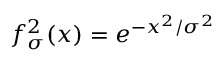Convert formula to latex. <formula><loc_0><loc_0><loc_500><loc_500>f _ { \sigma } ^ { 2 } ( x ) = e ^ { - x ^ { 2 } / \sigma ^ { 2 } }</formula> 